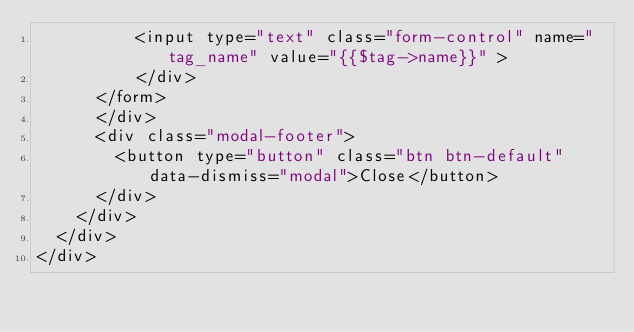Convert code to text. <code><loc_0><loc_0><loc_500><loc_500><_PHP_>					<input type="text" class="form-control" name="tag_name" value="{{$tag->name}}" >                        
			    </div>
			</form>
      </div>
      <div class="modal-footer">
        <button type="button" class="btn btn-default" data-dismiss="modal">Close</button>
      </div>
    </div>
  </div>
</div></code> 